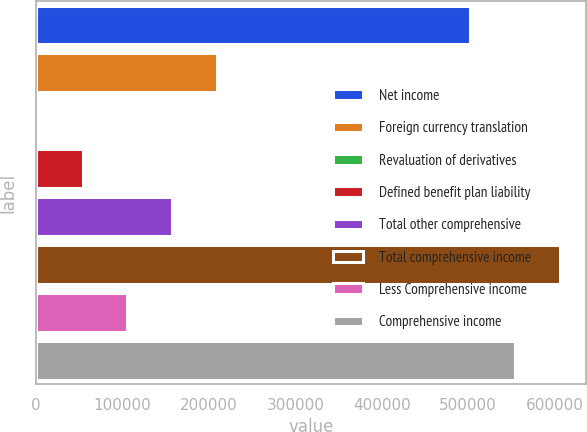Convert chart to OTSL. <chart><loc_0><loc_0><loc_500><loc_500><bar_chart><fcel>Net income<fcel>Foreign currency translation<fcel>Revaluation of derivatives<fcel>Defined benefit plan liability<fcel>Total other comprehensive<fcel>Total comprehensive income<fcel>Less Comprehensive income<fcel>Comprehensive income<nl><fcel>502413<fcel>208932<fcel>2363<fcel>54005.2<fcel>157290<fcel>605697<fcel>105647<fcel>554055<nl></chart> 